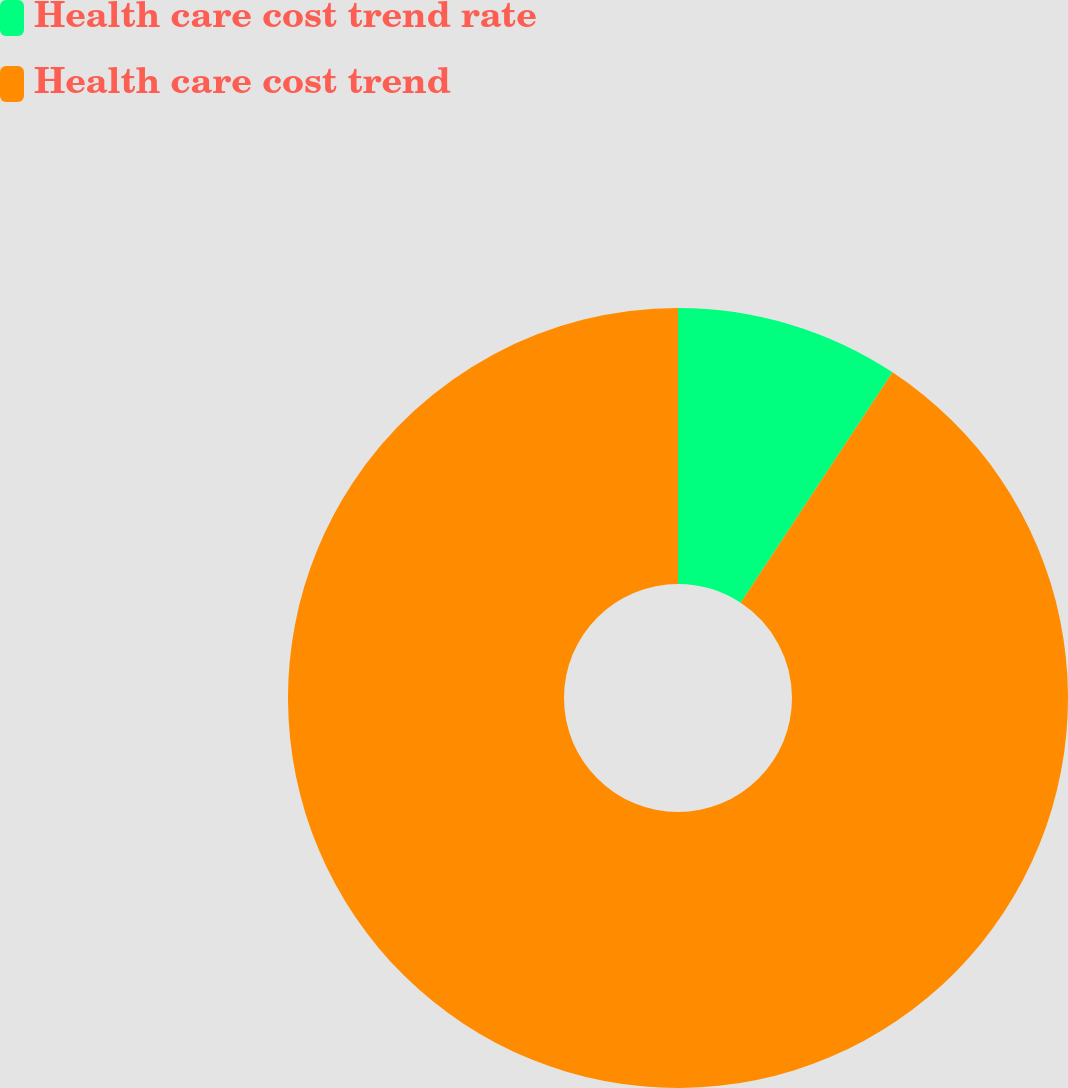Convert chart. <chart><loc_0><loc_0><loc_500><loc_500><pie_chart><fcel>Health care cost trend rate<fcel>Health care cost trend<nl><fcel>9.27%<fcel>90.73%<nl></chart> 